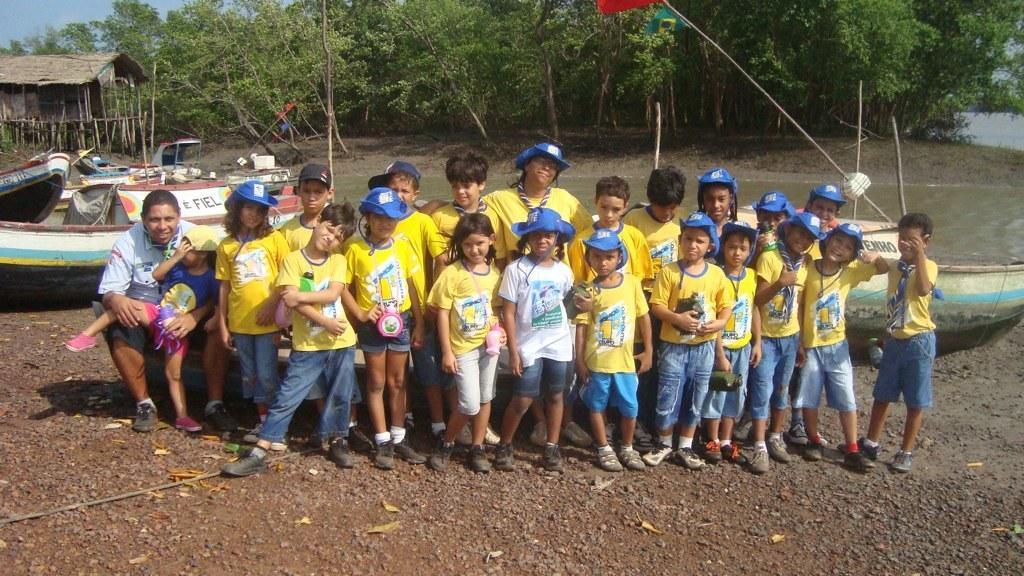Describe this image in one or two sentences. In this image few kids are wearing yellow shirts are standing on the land. A kid is wearing a white shirt and blue color cap. A person is sitting on the boat and he is having a kid on his lap. Left side there are few boats. Behind it there is water. There is a hut and few trees are on the land. 